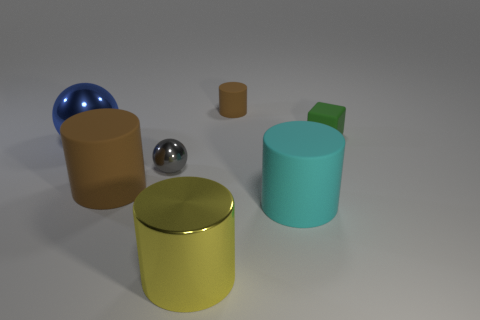Subtract all small rubber cylinders. How many cylinders are left? 3 Subtract all cyan blocks. How many brown cylinders are left? 2 Add 3 tiny gray metallic spheres. How many objects exist? 10 Subtract all cyan cylinders. How many cylinders are left? 3 Subtract all cubes. How many objects are left? 6 Subtract all gray cylinders. Subtract all green cubes. How many cylinders are left? 4 Subtract all balls. Subtract all yellow shiny things. How many objects are left? 4 Add 3 rubber cylinders. How many rubber cylinders are left? 6 Add 3 matte things. How many matte things exist? 7 Subtract 0 yellow cubes. How many objects are left? 7 